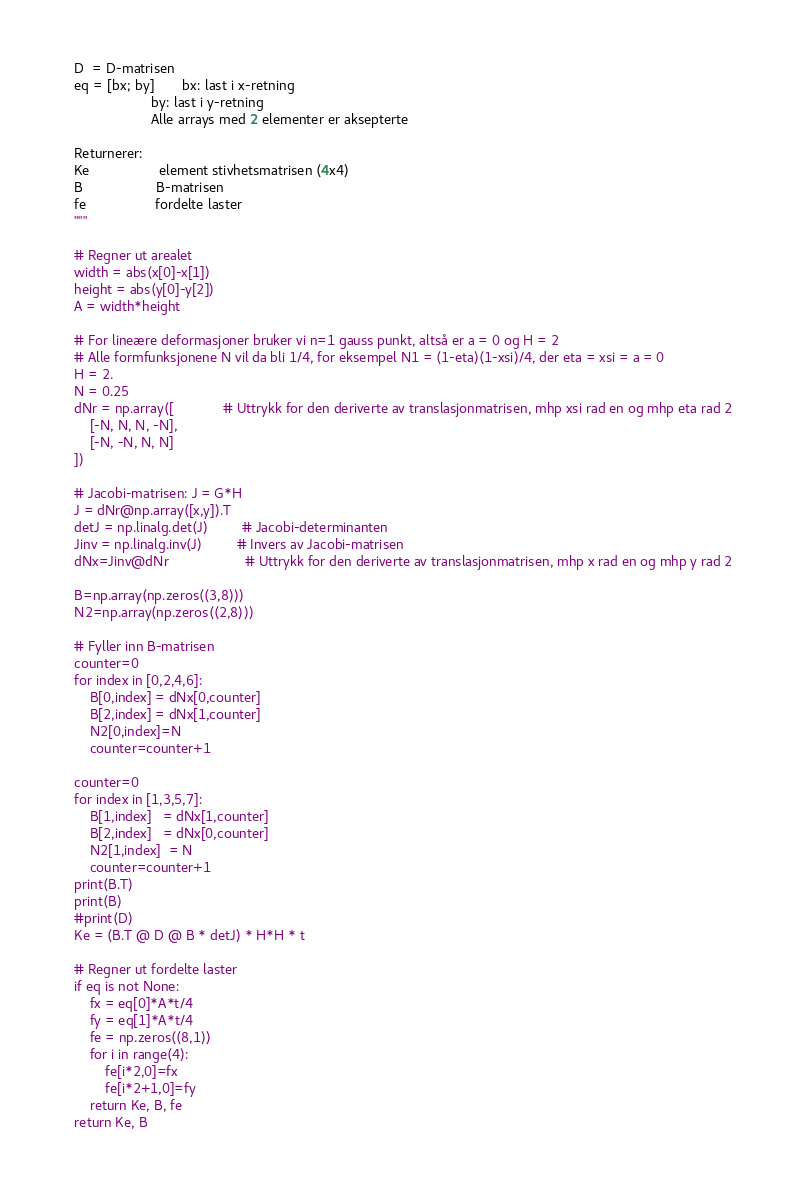<code> <loc_0><loc_0><loc_500><loc_500><_Python_>    D  = D-matrisen
    eq = [bx; by]       bx: last i x-retning
                        by: last i y-retning
                        Alle arrays med 2 elementer er aksepterte

    Returnerer:
    Ke                  element stivhetsmatrisen (4x4)
    B                   B-matrisen
    fe                  fordelte laster
    """

    # Regner ut arealet
    width = abs(x[0]-x[1])
    height = abs(y[0]-y[2])
    A = width*height

    # For lineære deformasjoner bruker vi n=1 gauss punkt, altså er a = 0 og H = 2
    # Alle formfunksjonene N vil da bli 1/4, for eksempel N1 = (1-eta)(1-xsi)/4, der eta = xsi = a = 0
    H = 2.
    N = 0.25
    dNr = np.array([             # Uttrykk for den deriverte av translasjonmatrisen, mhp xsi rad en og mhp eta rad 2
        [-N, N, N, -N],
        [-N, -N, N, N]
    ])
    
    # Jacobi-matrisen: J = G*H
    J = dNr@np.array([x,y]).T 
    detJ = np.linalg.det(J)         # Jacobi-determinanten
    Jinv = np.linalg.inv(J)         # Invers av Jacobi-matrisen
    dNx=Jinv@dNr                    # Uttrykk for den deriverte av translasjonmatrisen, mhp x rad en og mhp y rad 2

    B=np.array(np.zeros((3,8)))
    N2=np.array(np.zeros((2,8)))
    
    # Fyller inn B-matrisen  
    counter=0    
    for index in [0,2,4,6]:
        B[0,index] = dNx[0,counter]
        B[2,index] = dNx[1,counter]
        N2[0,index]=N
        counter=counter+1

    counter=0    
    for index in [1,3,5,7]:
        B[1,index]   = dNx[1,counter]
        B[2,index]   = dNx[0,counter]
        N2[1,index]  = N
        counter=counter+1
    print(B.T)
    print(B)
    #print(D)
    Ke = (B.T @ D @ B * detJ) * H*H * t
    
    # Regner ut fordelte laster
    if eq is not None:
        fx = eq[0]*A*t/4
        fy = eq[1]*A*t/4
        fe = np.zeros((8,1))
        for i in range(4):
            fe[i*2,0]=fx
            fe[i*2+1,0]=fy
        return Ke, B, fe
    return Ke, B</code> 